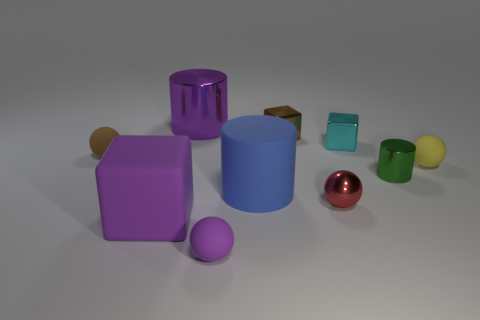What number of other objects are the same color as the large shiny cylinder?
Provide a short and direct response. 2. There is a cyan thing that is the same size as the brown sphere; what is its shape?
Keep it short and to the point. Cube. What is the size of the cylinder that is in front of the small green metallic cylinder?
Your answer should be compact. Large. Does the shiny cylinder that is behind the brown ball have the same color as the cube to the right of the red sphere?
Your answer should be compact. No. There is a big thing on the right side of the large cylinder that is left of the small rubber sphere in front of the tiny green cylinder; what is it made of?
Your answer should be very brief. Rubber. Are there any yellow shiny blocks of the same size as the cyan cube?
Ensure brevity in your answer.  No. There is a green thing that is the same size as the red ball; what is its material?
Your answer should be very brief. Metal. There is a small rubber object that is in front of the small green cylinder; what shape is it?
Offer a very short reply. Sphere. Does the small ball that is in front of the purple block have the same material as the tiny brown object to the left of the tiny brown metallic cube?
Ensure brevity in your answer.  Yes. What number of tiny yellow things are the same shape as the blue object?
Give a very brief answer. 0. 